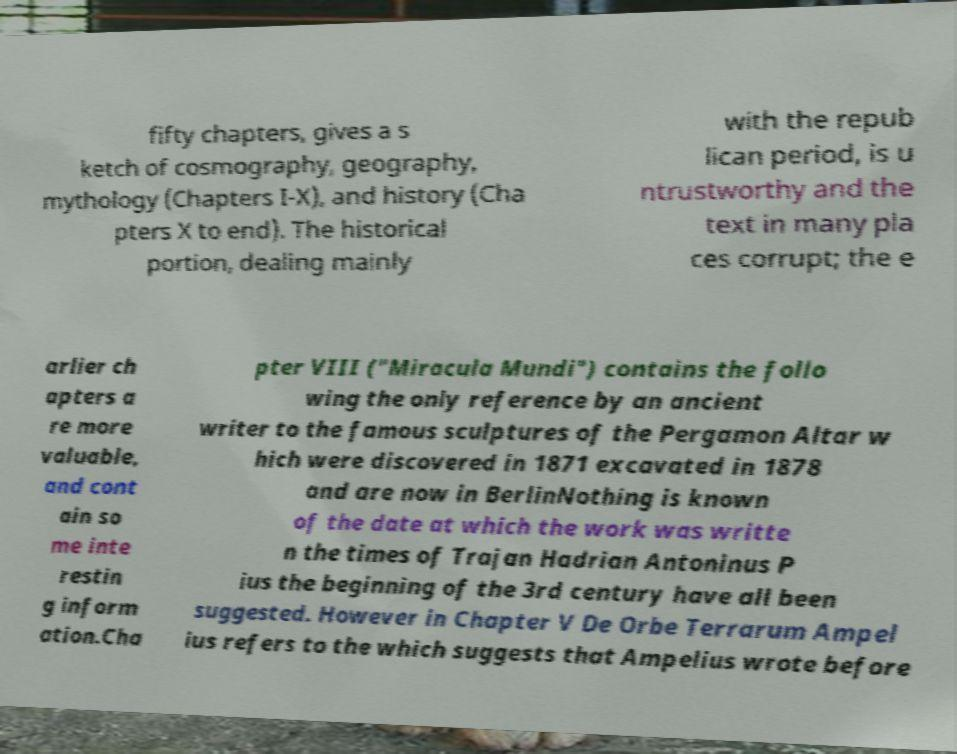What messages or text are displayed in this image? I need them in a readable, typed format. fifty chapters, gives a s ketch of cosmography, geography, mythology (Chapters I-X), and history (Cha pters X to end). The historical portion, dealing mainly with the repub lican period, is u ntrustworthy and the text in many pla ces corrupt; the e arlier ch apters a re more valuable, and cont ain so me inte restin g inform ation.Cha pter VIII ("Miracula Mundi") contains the follo wing the only reference by an ancient writer to the famous sculptures of the Pergamon Altar w hich were discovered in 1871 excavated in 1878 and are now in BerlinNothing is known of the date at which the work was writte n the times of Trajan Hadrian Antoninus P ius the beginning of the 3rd century have all been suggested. However in Chapter V De Orbe Terrarum Ampel ius refers to the which suggests that Ampelius wrote before 